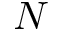Convert formula to latex. <formula><loc_0><loc_0><loc_500><loc_500>N</formula> 